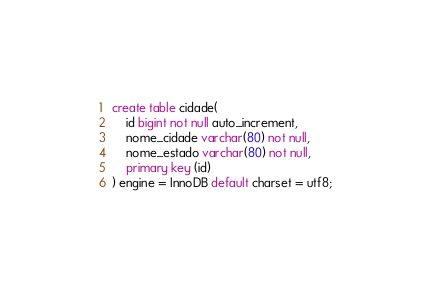Convert code to text. <code><loc_0><loc_0><loc_500><loc_500><_SQL_>create table cidade(
    id bigint not null auto_increment,
    nome_cidade varchar(80) not null,
    nome_estado varchar(80) not null,
    primary key (id)
) engine = InnoDB default charset = utf8;</code> 